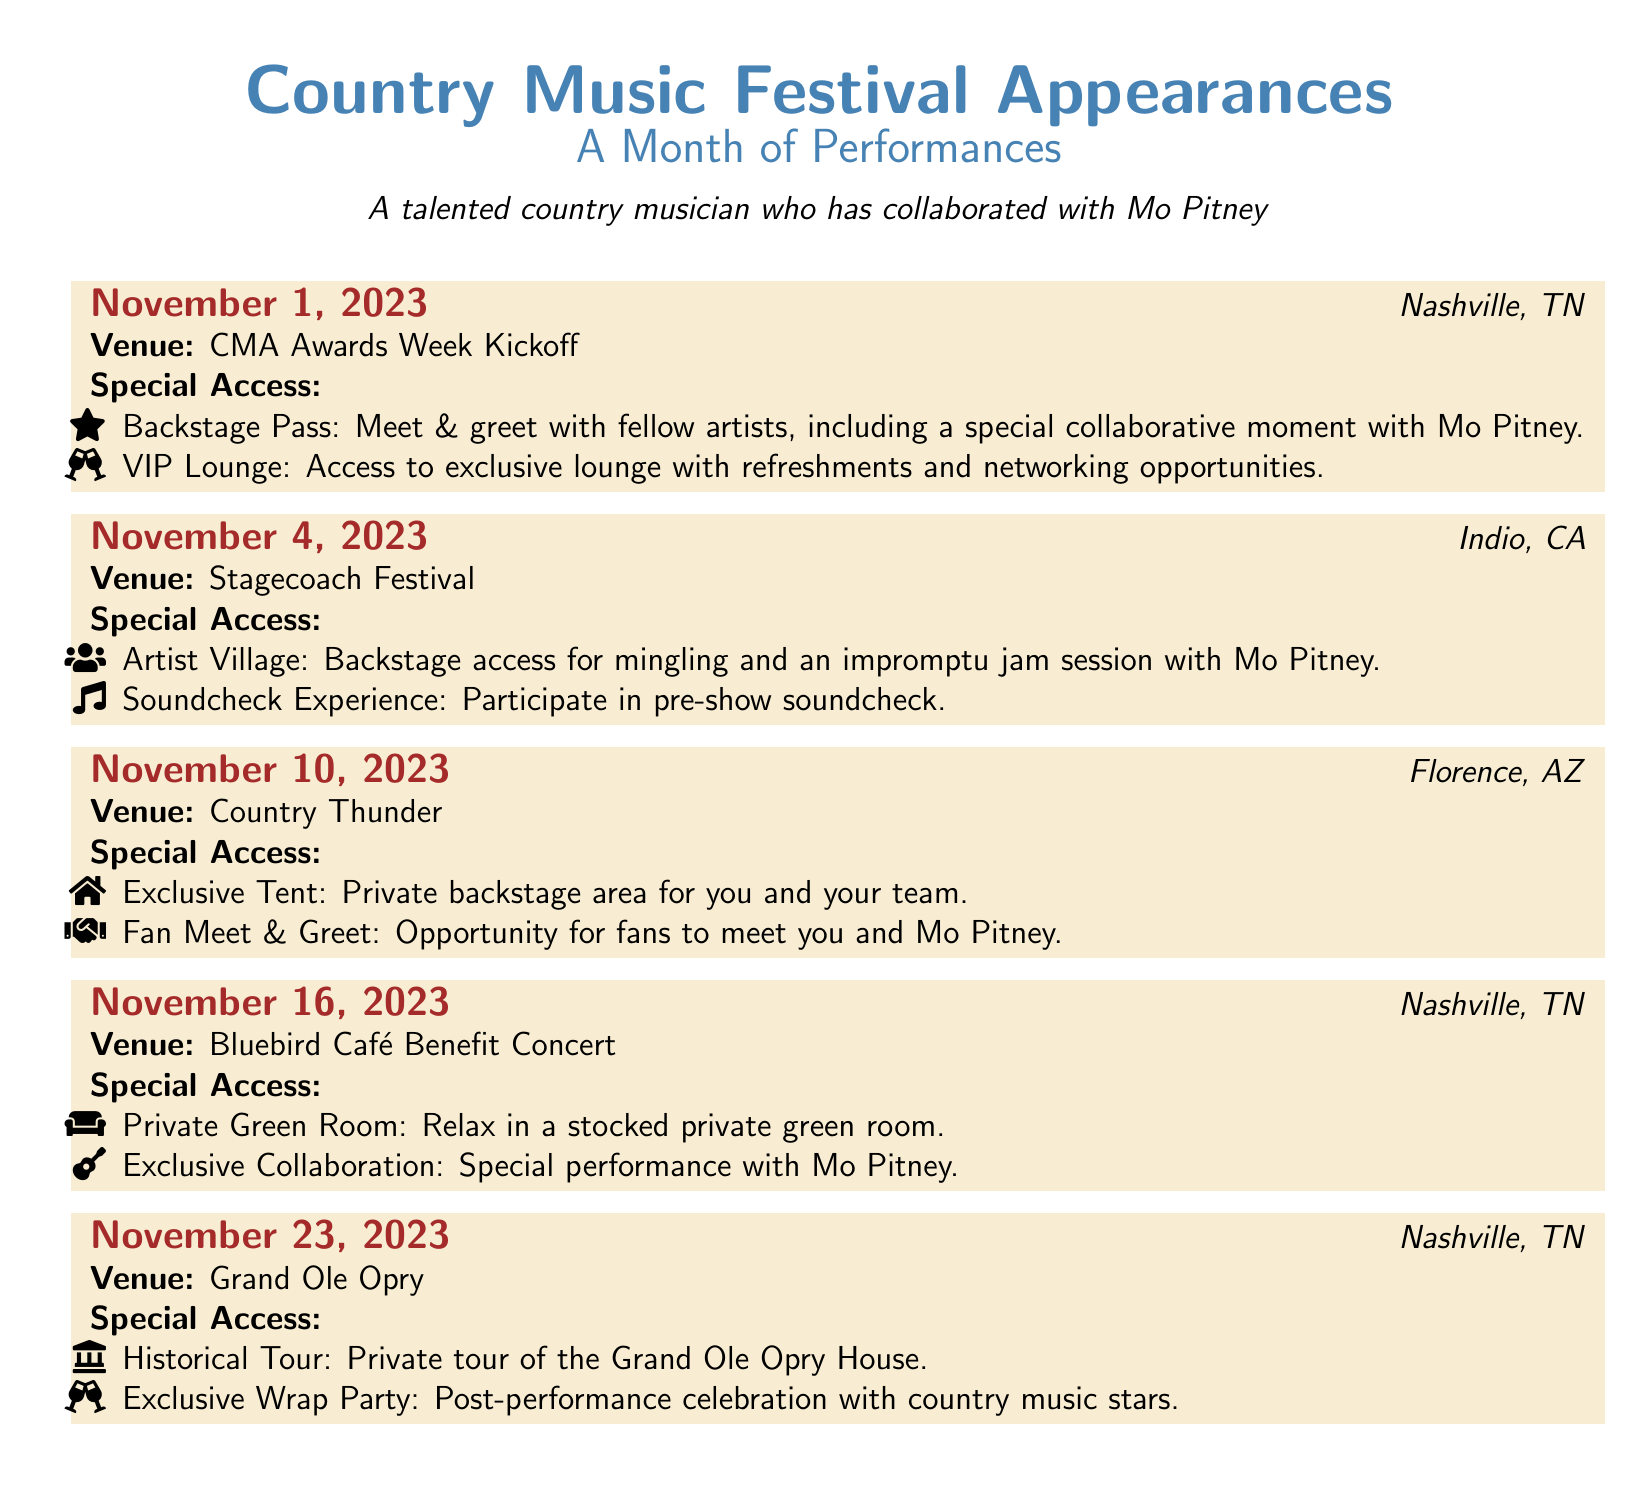What date is the CMA Awards Week Kickoff? The CMA Awards Week Kickoff is scheduled for November 1, 2023.
Answer: November 1, 2023 Where is the Stagecoach Festival held? The Stagecoach Festival takes place in Indio, CA.
Answer: Indio, CA What special access is available at the Grand Ole Opry? At the Grand Ole Opry, there is a historical tour of the Grand Ole Opry House.
Answer: Historical Tour Which venue features a private green room? The private green room is at the Bluebird Café Benefit Concert.
Answer: Bluebird Café Benefit Concert How many performances are scheduled in Nashville, TN? There are three performances scheduled in Nashville, TN throughout the month.
Answer: Three What unique experience do artists have at the Country Thunder event? At Country Thunder, there is a fan meet and greet opportunity.
Answer: Fan Meet & Greet Which artist will you have a special performance with during the month? The special performance will be with Mo Pitney.
Answer: Mo Pitney What type of access is offered at the Indio, CA event? At the Indio event, there is backstage access for mingling.
Answer: Backstage access What event occurs on November 16, 2023? The event on November 16, 2023, is the Bluebird Café Benefit Concert.
Answer: Bluebird Café Benefit Concert 